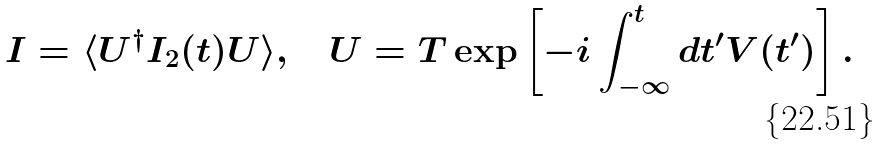Convert formula to latex. <formula><loc_0><loc_0><loc_500><loc_500>I = \langle U ^ { \dag } I _ { 2 } ( t ) U \rangle , \quad U = { T } \exp \left [ - i \int ^ { t } _ { - \infty } d t ^ { \prime } V ( t ^ { \prime } ) \right ] .</formula> 